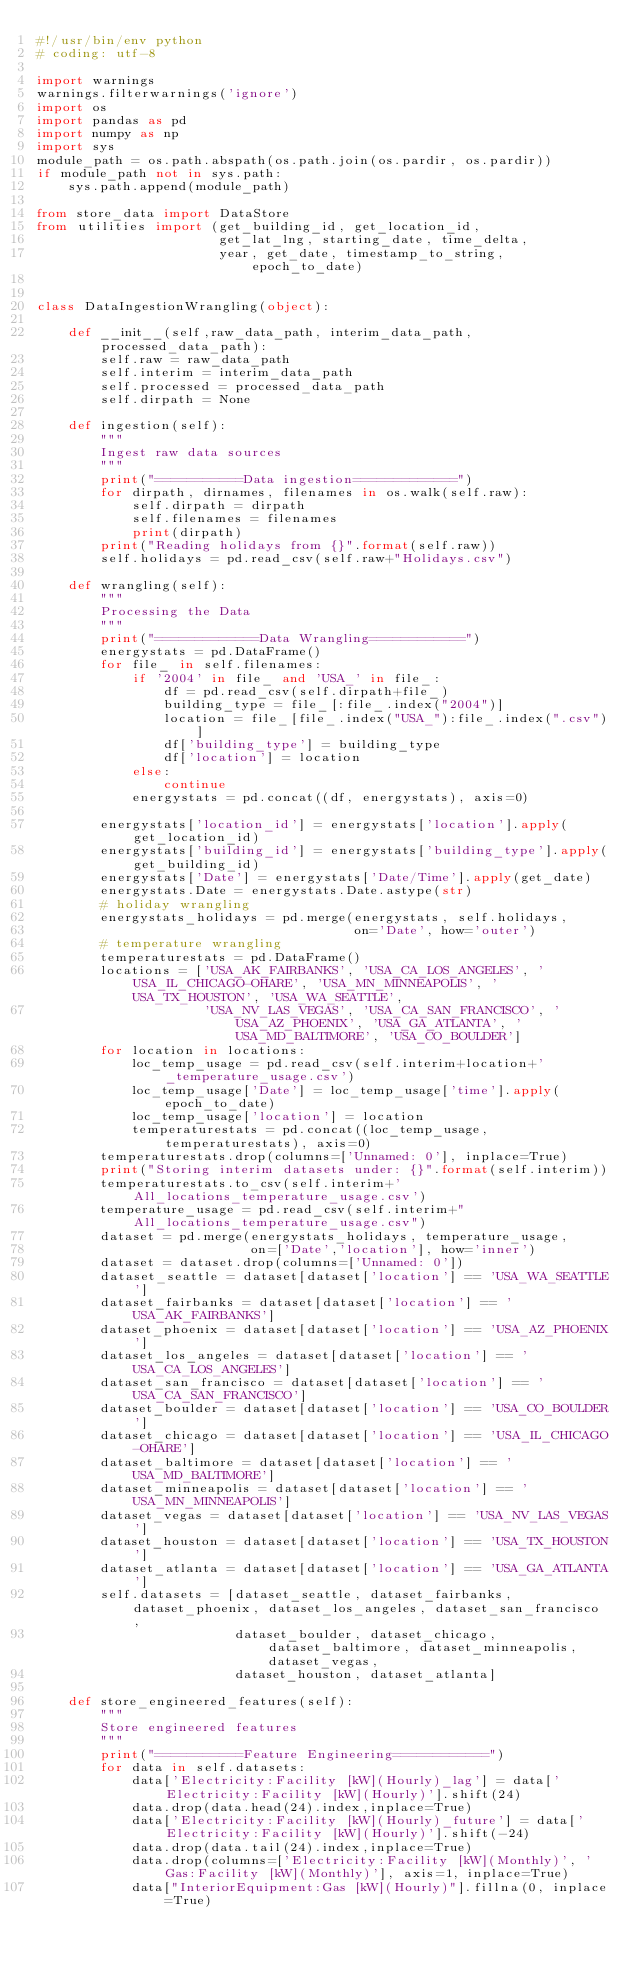Convert code to text. <code><loc_0><loc_0><loc_500><loc_500><_Python_>#!/usr/bin/env python
# coding: utf-8

import warnings
warnings.filterwarnings('ignore')
import os
import pandas as pd
import numpy as np
import sys
module_path = os.path.abspath(os.path.join(os.pardir, os.pardir))
if module_path not in sys.path:
    sys.path.append(module_path)

from store_data import DataStore
from utilities import (get_building_id, get_location_id,
                       get_lat_lng, starting_date, time_delta,
                       year, get_date, timestamp_to_string, epoch_to_date)


class DataIngestionWrangling(object):

    def __init__(self,raw_data_path, interim_data_path, processed_data_path):
        self.raw = raw_data_path
        self.interim = interim_data_path
        self.processed = processed_data_path
        self.dirpath = None

    def ingestion(self):
        """
        Ingest raw data sources
        """
        print("===========Data ingestion=============")
        for dirpath, dirnames, filenames in os.walk(self.raw):
            self.dirpath = dirpath
            self.filenames = filenames
            print(dirpath)
        print("Reading holidays from {}".format(self.raw))
        self.holidays = pd.read_csv(self.raw+"Holidays.csv")

    def wrangling(self):
        """
        Processing the Data
        """
        print("=============Data Wrangling============")
        energystats = pd.DataFrame()
        for file_ in self.filenames:
            if '2004' in file_ and 'USA_' in file_:
                df = pd.read_csv(self.dirpath+file_)
                building_type = file_[:file_.index("2004")]
                location = file_[file_.index("USA_"):file_.index(".csv")]
                df['building_type'] = building_type
                df['location'] = location
            else:
                continue
            energystats = pd.concat((df, energystats), axis=0)

        energystats['location_id'] = energystats['location'].apply(get_location_id)
        energystats['building_id'] = energystats['building_type'].apply(get_building_id)
        energystats['Date'] = energystats['Date/Time'].apply(get_date)
        energystats.Date = energystats.Date.astype(str)
        # holiday wrangling
        energystats_holidays = pd.merge(energystats, self.holidays,
                                        on='Date', how='outer')
        # temperature wrangling
        temperaturestats = pd.DataFrame()
        locations = ['USA_AK_FAIRBANKS', 'USA_CA_LOS_ANGELES', 'USA_IL_CHICAGO-OHARE', 'USA_MN_MINNEAPOLIS', 'USA_TX_HOUSTON', 'USA_WA_SEATTLE',
                     'USA_NV_LAS_VEGAS', 'USA_CA_SAN_FRANCISCO', 'USA_AZ_PHOENIX', 'USA_GA_ATLANTA', 'USA_MD_BALTIMORE', 'USA_CO_BOULDER']
        for location in locations:
            loc_temp_usage = pd.read_csv(self.interim+location+'_temperature_usage.csv')
            loc_temp_usage['Date'] = loc_temp_usage['time'].apply(epoch_to_date)
            loc_temp_usage['location'] = location
            temperaturestats = pd.concat((loc_temp_usage, temperaturestats), axis=0)
        temperaturestats.drop(columns=['Unnamed: 0'], inplace=True)
        print("Storing interim datasets under: {}".format(self.interim))
        temperaturestats.to_csv(self.interim+'All_locations_temperature_usage.csv')
        temperature_usage = pd.read_csv(self.interim+"All_locations_temperature_usage.csv")
        dataset = pd.merge(energystats_holidays, temperature_usage,
                           on=['Date','location'], how='inner')
        dataset = dataset.drop(columns=['Unnamed: 0'])
        dataset_seattle = dataset[dataset['location'] == 'USA_WA_SEATTLE']
        dataset_fairbanks = dataset[dataset['location'] == 'USA_AK_FAIRBANKS']
        dataset_phoenix = dataset[dataset['location'] == 'USA_AZ_PHOENIX']
        dataset_los_angeles = dataset[dataset['location'] == 'USA_CA_LOS_ANGELES']
        dataset_san_francisco = dataset[dataset['location'] == 'USA_CA_SAN_FRANCISCO']
        dataset_boulder = dataset[dataset['location'] == 'USA_CO_BOULDER']
        dataset_chicago = dataset[dataset['location'] == 'USA_IL_CHICAGO-OHARE']
        dataset_baltimore = dataset[dataset['location'] == 'USA_MD_BALTIMORE']
        dataset_minneapolis = dataset[dataset['location'] == 'USA_MN_MINNEAPOLIS']
        dataset_vegas = dataset[dataset['location'] == 'USA_NV_LAS_VEGAS']
        dataset_houston = dataset[dataset['location'] == 'USA_TX_HOUSTON']
        dataset_atlanta = dataset[dataset['location'] == 'USA_GA_ATLANTA']
        self.datasets = [dataset_seattle, dataset_fairbanks, dataset_phoenix, dataset_los_angeles, dataset_san_francisco,
                         dataset_boulder, dataset_chicago, dataset_baltimore, dataset_minneapolis, dataset_vegas,
                         dataset_houston, dataset_atlanta]

    def store_engineered_features(self):
        """
        Store engineered features
        """
        print("===========Feature Engineering============")
        for data in self.datasets:
            data['Electricity:Facility [kW](Hourly)_lag'] = data['Electricity:Facility [kW](Hourly)'].shift(24)
            data.drop(data.head(24).index,inplace=True)
            data['Electricity:Facility [kW](Hourly)_future'] = data['Electricity:Facility [kW](Hourly)'].shift(-24)
            data.drop(data.tail(24).index,inplace=True)
            data.drop(columns=['Electricity:Facility [kW](Monthly)', 'Gas:Facility [kW](Monthly)'], axis=1, inplace=True)
            data["InteriorEquipment:Gas [kW](Hourly)"].fillna(0, inplace=True)</code> 